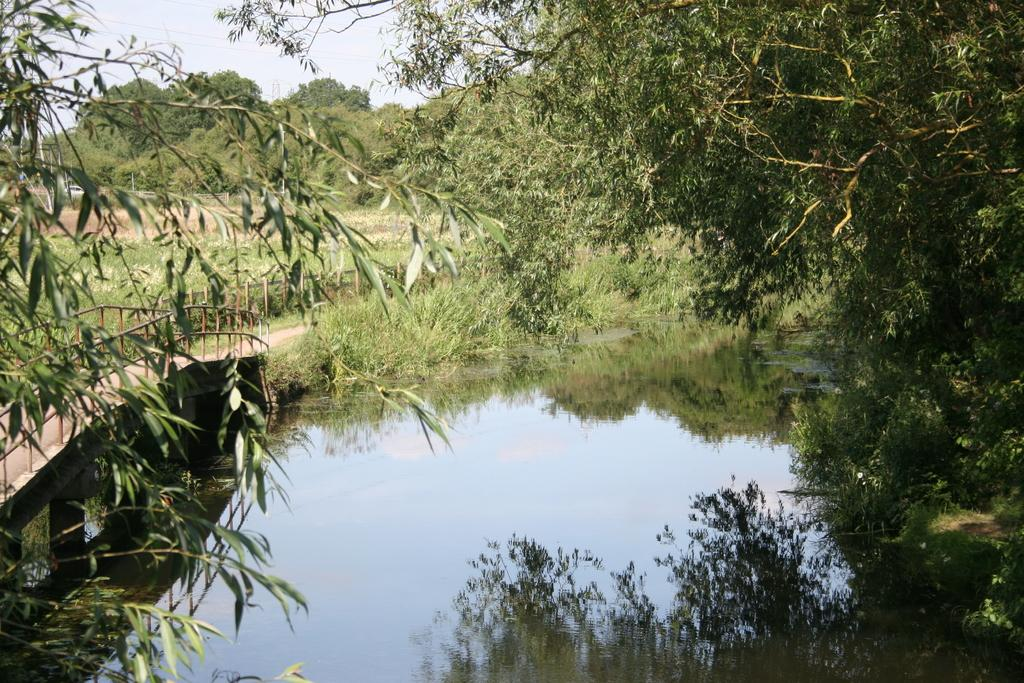What type of body of water is present in the image? There is a pond in the image. What structure can be seen crossing over the pond? There is a bridge in the image. What type of vegetation is visible in the image? There are trees, grass, and plants visible in the image. What part of the natural environment is visible in the image? The sky is visible in the image. What type of trade is happening in the image? There is no indication of any trade activity in the image. What type of road can be seen in the image? There is no road present in the image. How many geese are visible in the image? There are no geese visible in the image. 